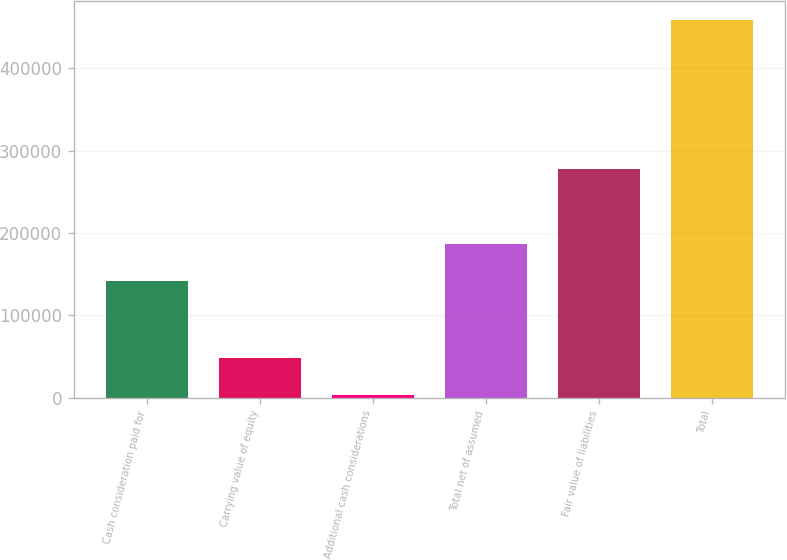<chart> <loc_0><loc_0><loc_500><loc_500><bar_chart><fcel>Cash consideration paid for<fcel>Carrying value of equity<fcel>Additional cash considerations<fcel>Total net of assumed<fcel>Fair value of liabilities<fcel>Total<nl><fcel>141286<fcel>48669<fcel>3123<fcel>186832<fcel>277993<fcel>458583<nl></chart> 